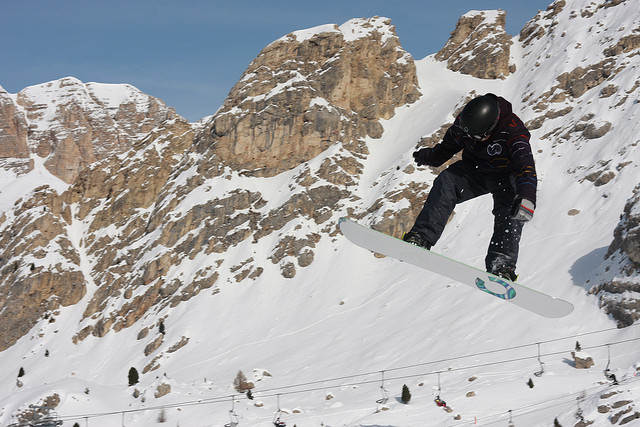Can you describe the landscape and the environment in the image? Certainly. The image showcases a stunning snowy mountainous terrain with rugged cliffs and towering peaks. The sky is clear, enhancing the visibility of the dramatic landscape. Snow covers most of the mountain slopes, although some areas reveal exposed rocks, indicating less snow accumulation there. In the distance, there's a lift line visible, hinting at a well-frequented skiing or snowboarding area. 